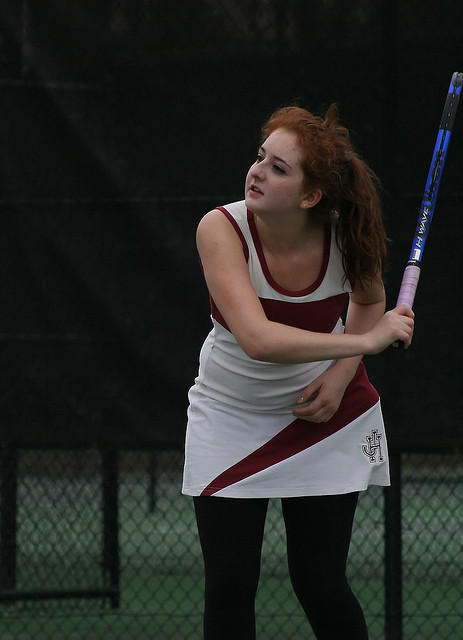<image>What brand is the racket? I am not sure what the brand of the racket is. It can be 'sava', 'm wave', 'wilson', 'reebok', 'nike', or 'prince'. What brand is the racket? I am not sure what brand the racket is. It can be seen 'sava', 'm wave', 'wilson', 'reebok', 'nike', or 'prince'. 